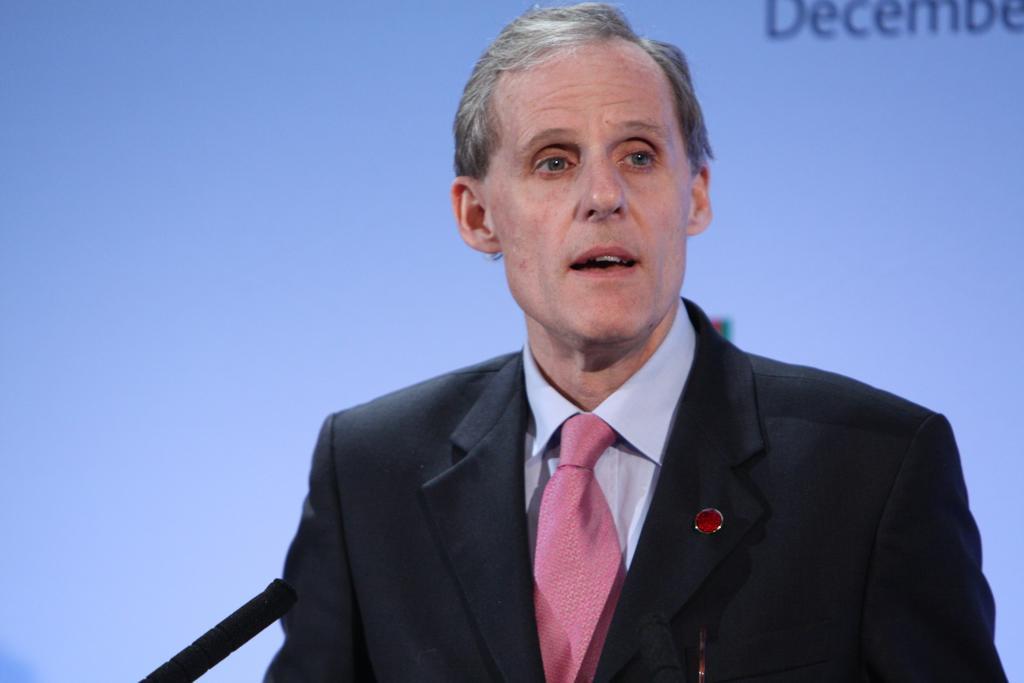How would you summarize this image in a sentence or two? In this picture we can see a man, mic and a screen in the background. 